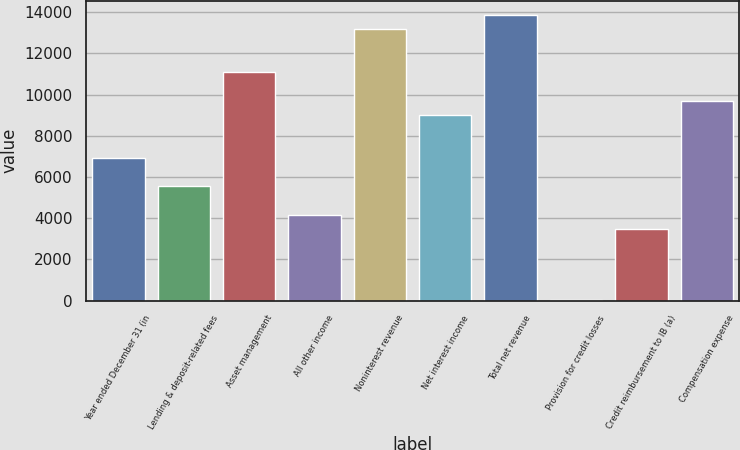Convert chart. <chart><loc_0><loc_0><loc_500><loc_500><bar_chart><fcel>Year ended December 31 (in<fcel>Lending & deposit-related fees<fcel>Asset management<fcel>All other income<fcel>Noninterest revenue<fcel>Net interest income<fcel>Total net revenue<fcel>Provision for credit losses<fcel>Credit reimbursement to IB (a)<fcel>Compensation expense<nl><fcel>6945<fcel>5559.8<fcel>11100.6<fcel>4174.6<fcel>13178.4<fcel>9022.8<fcel>13871<fcel>19<fcel>3482<fcel>9715.4<nl></chart> 